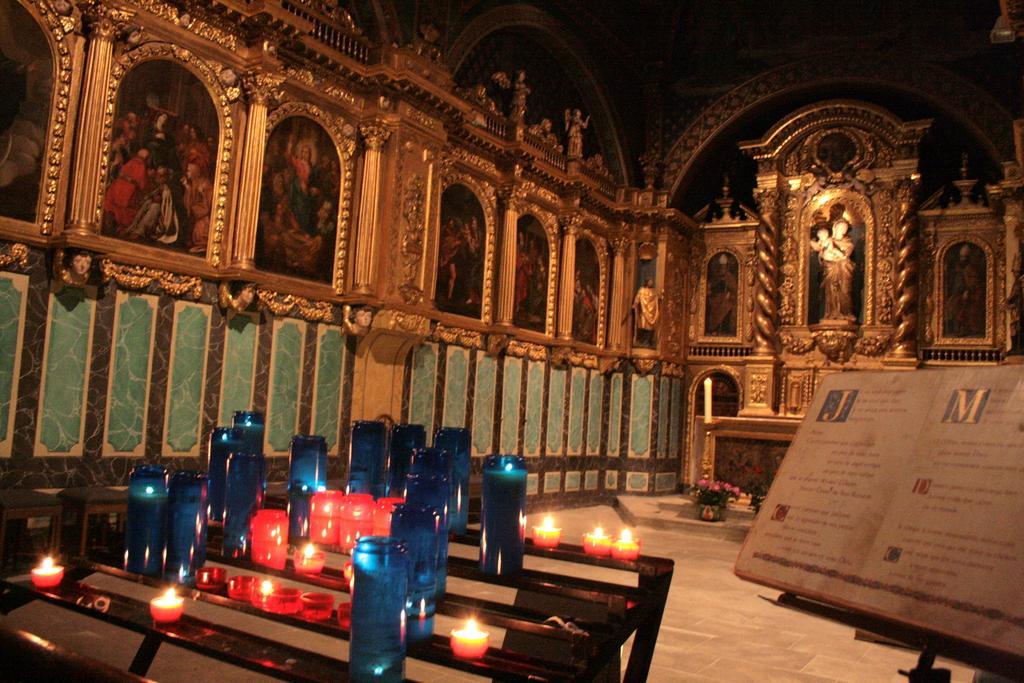Describe this image in one or two sentences. It is an inside view of the church. Here we can see few sculptures, photo frames, wall. At the bottom, there is a floor. Few candles on the stand. Right side of the image, we can see a book with stand, plant with flowers and pot. 